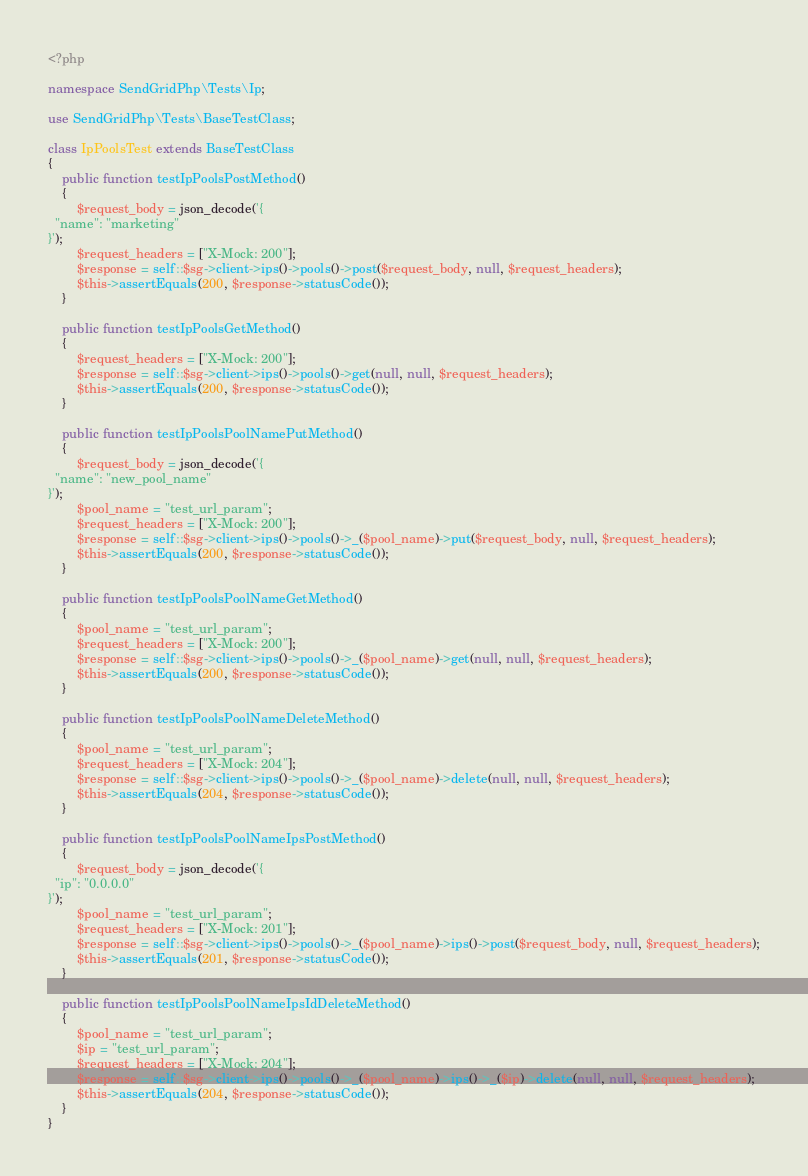Convert code to text. <code><loc_0><loc_0><loc_500><loc_500><_PHP_><?php

namespace SendGridPhp\Tests\Ip;

use SendGridPhp\Tests\BaseTestClass;

class IpPoolsTest extends BaseTestClass
{
    public function testIpPoolsPostMethod()
    {
        $request_body = json_decode('{
  "name": "marketing"
}');
        $request_headers = ["X-Mock: 200"];
        $response = self::$sg->client->ips()->pools()->post($request_body, null, $request_headers);
        $this->assertEquals(200, $response->statusCode());
    }

    public function testIpPoolsGetMethod()
    {
        $request_headers = ["X-Mock: 200"];
        $response = self::$sg->client->ips()->pools()->get(null, null, $request_headers);
        $this->assertEquals(200, $response->statusCode());
    }

    public function testIpPoolsPoolNamePutMethod()
    {
        $request_body = json_decode('{
  "name": "new_pool_name"
}');
        $pool_name = "test_url_param";
        $request_headers = ["X-Mock: 200"];
        $response = self::$sg->client->ips()->pools()->_($pool_name)->put($request_body, null, $request_headers);
        $this->assertEquals(200, $response->statusCode());
    }

    public function testIpPoolsPoolNameGetMethod()
    {
        $pool_name = "test_url_param";
        $request_headers = ["X-Mock: 200"];
        $response = self::$sg->client->ips()->pools()->_($pool_name)->get(null, null, $request_headers);
        $this->assertEquals(200, $response->statusCode());
    }

    public function testIpPoolsPoolNameDeleteMethod()
    {
        $pool_name = "test_url_param";
        $request_headers = ["X-Mock: 204"];
        $response = self::$sg->client->ips()->pools()->_($pool_name)->delete(null, null, $request_headers);
        $this->assertEquals(204, $response->statusCode());
    }

    public function testIpPoolsPoolNameIpsPostMethod()
    {
        $request_body = json_decode('{
  "ip": "0.0.0.0"
}');
        $pool_name = "test_url_param";
        $request_headers = ["X-Mock: 201"];
        $response = self::$sg->client->ips()->pools()->_($pool_name)->ips()->post($request_body, null, $request_headers);
        $this->assertEquals(201, $response->statusCode());
    }

    public function testIpPoolsPoolNameIpsIdDeleteMethod()
    {
        $pool_name = "test_url_param";
        $ip = "test_url_param";
        $request_headers = ["X-Mock: 204"];
        $response = self::$sg->client->ips()->pools()->_($pool_name)->ips()->_($ip)->delete(null, null, $request_headers);
        $this->assertEquals(204, $response->statusCode());
    }
}
</code> 